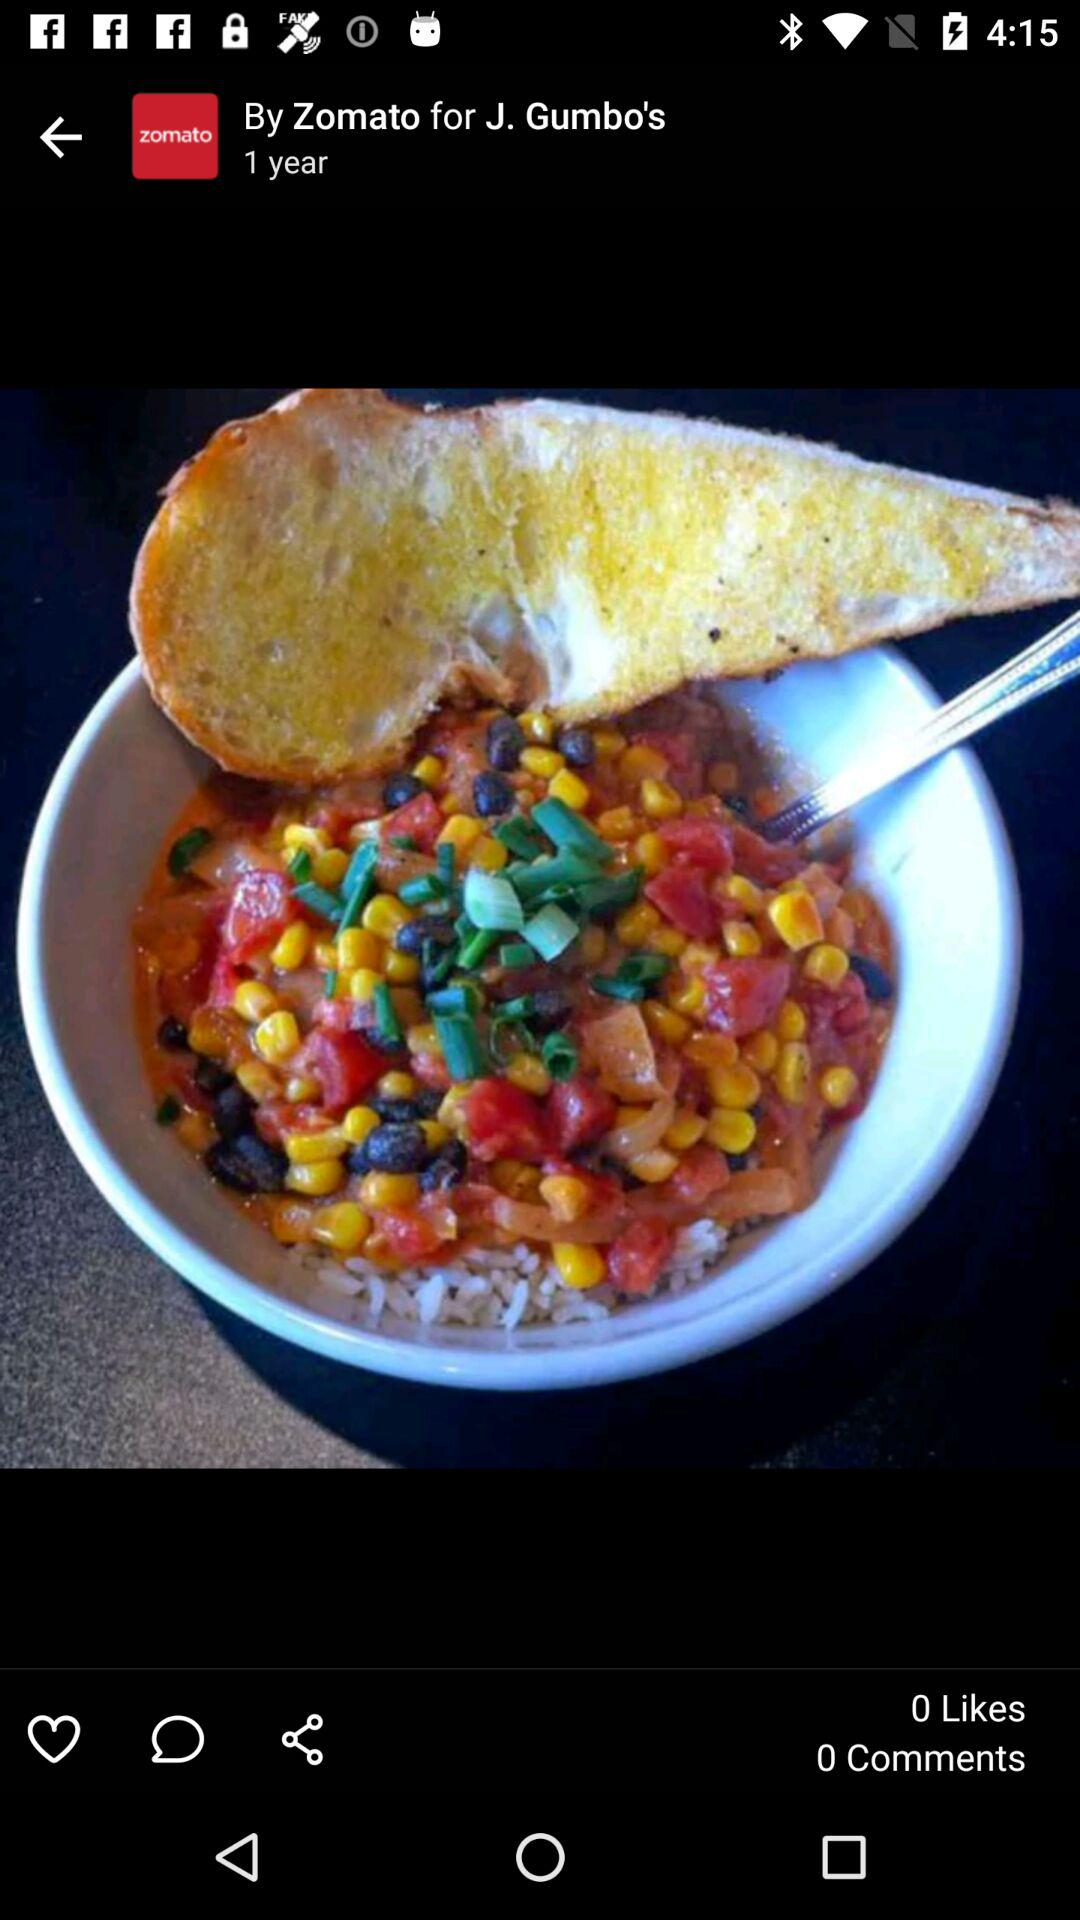How many more likes does the post have than comments?
Answer the question using a single word or phrase. 0 